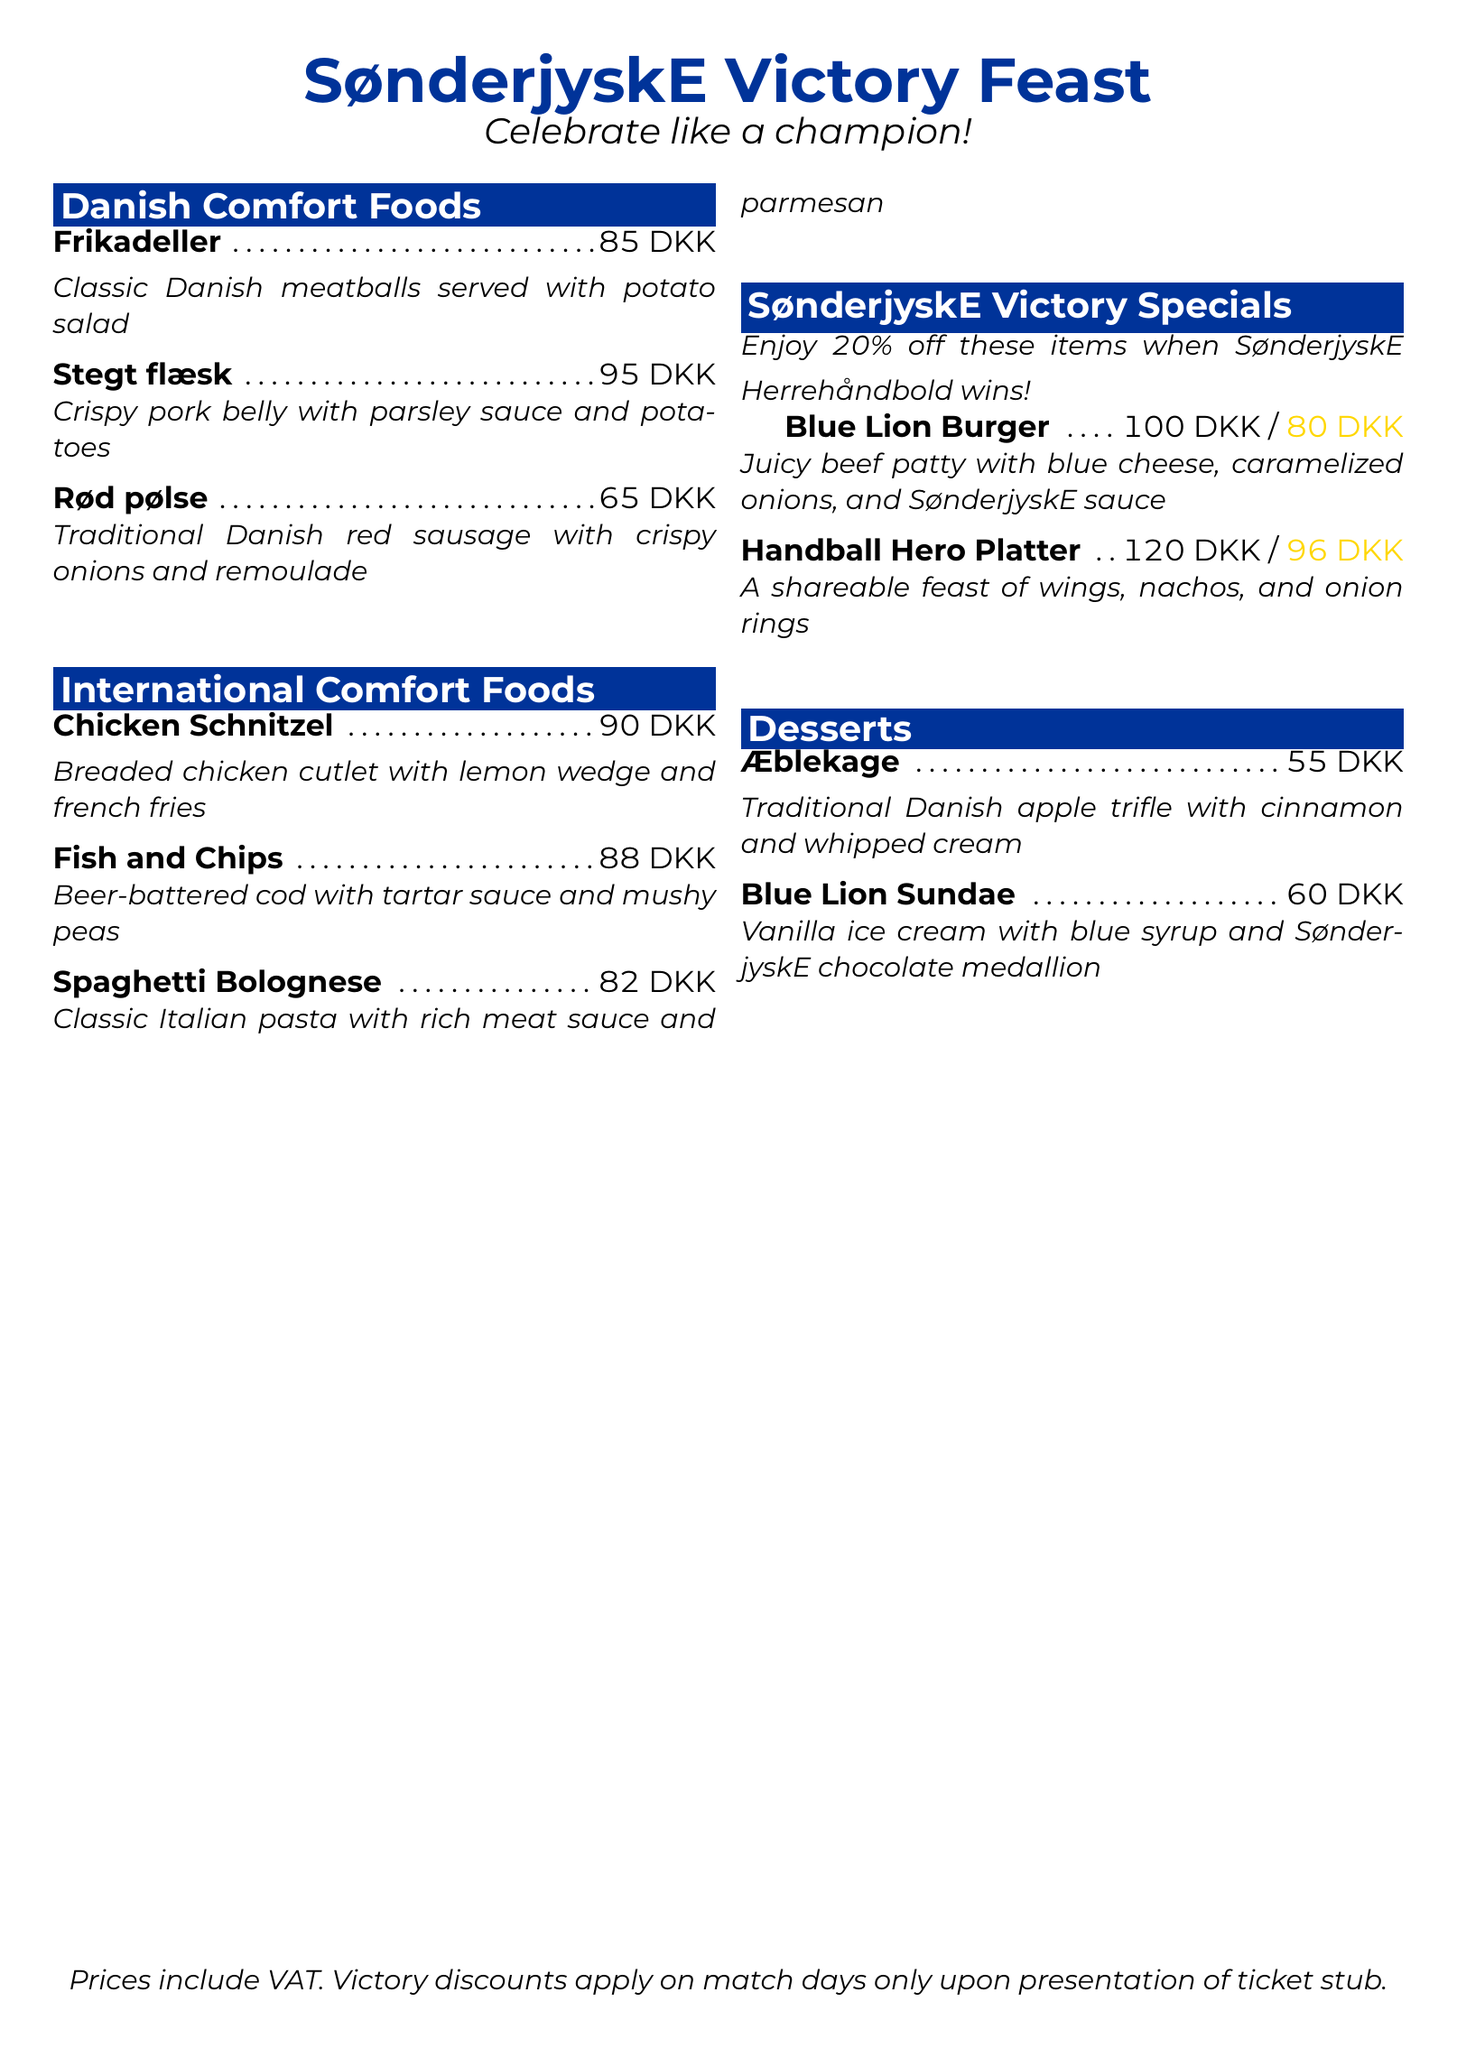What is the price of Frikadeller? The price of Frikadeller is stated in the Danish Comfort Foods section of the menu.
Answer: 85 DKK What percentage discount is offered on victory specials? The victory discount percentage is mentioned in the SønderjyskE Victory Specials section.
Answer: 20% What is the cost of the Blue Lion Sundae? The price of the Blue Lion Sundae is included in the Desserts section of the menu.
Answer: 60 DKK Which dish includes crispy pork belly? This dish is specifically mentioned in the Danish Comfort Foods section, describing its ingredients.
Answer: Stegt flæsk What type of ice cream is in the Blue Lion Sundae? The type of ice cream is indicated in the Desserts section of the menu, describing the dessert.
Answer: Vanilla ice cream How much does the Handball Hero Platter cost after the discount? The discounted price is listed next to its original price in the victory specials section.
Answer: 96 DKK 